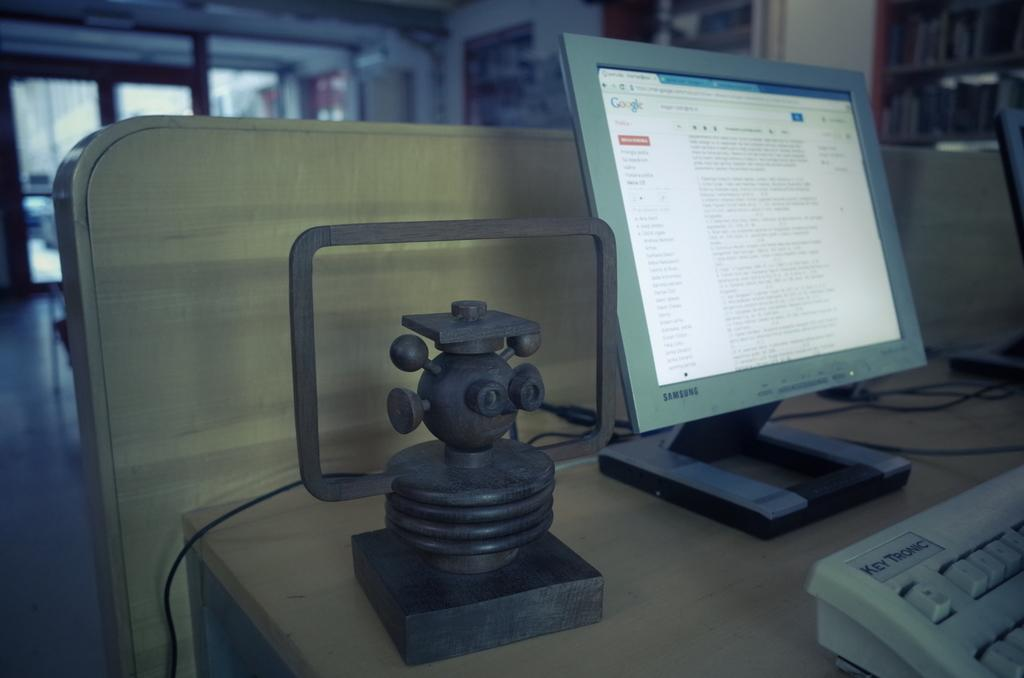<image>
Offer a succinct explanation of the picture presented. A gray Samsung monitor with the web-page Google open 